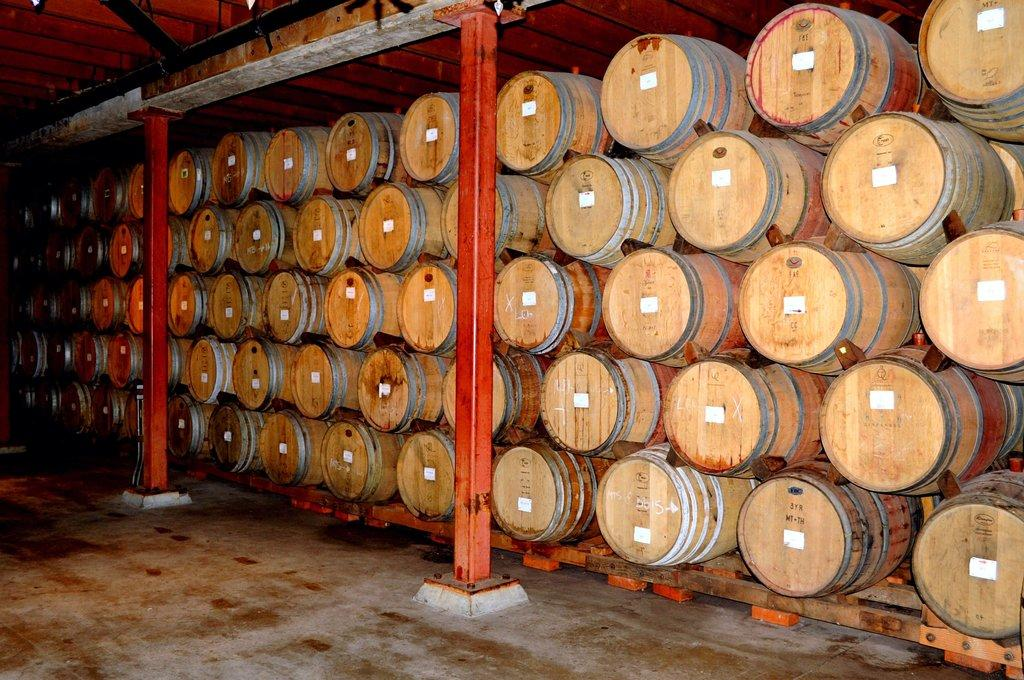What type of surface is visible in the image? The image contains a floor. What architectural elements can be seen in the image? There are pillars in the image. What objects are grouped together in the image? There is a group of barrels in the image. What can be seen in the background of the image? There is a wall and rods in the background of the image. What type of shop can be seen in the image? There is no shop present in the image. Is there a trail visible in the image? There is no trail visible in the image. 